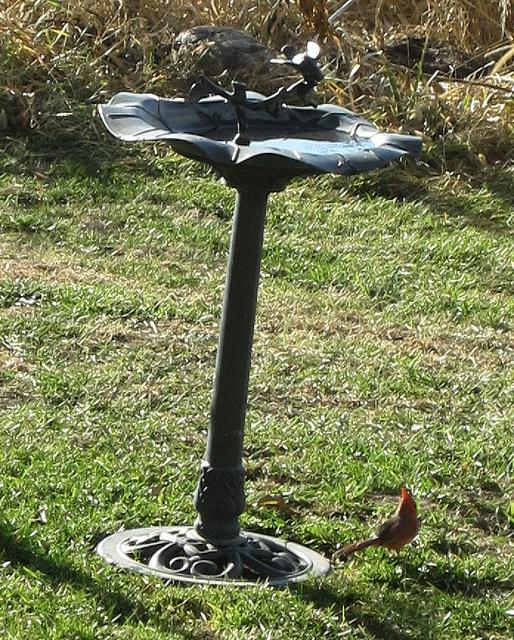What is the object in the center of the photo?
Give a very brief answer. Bird bath. Where is the bird looking?
Give a very brief answer. Up. Is there water in the birdbath?
Give a very brief answer. Yes. 